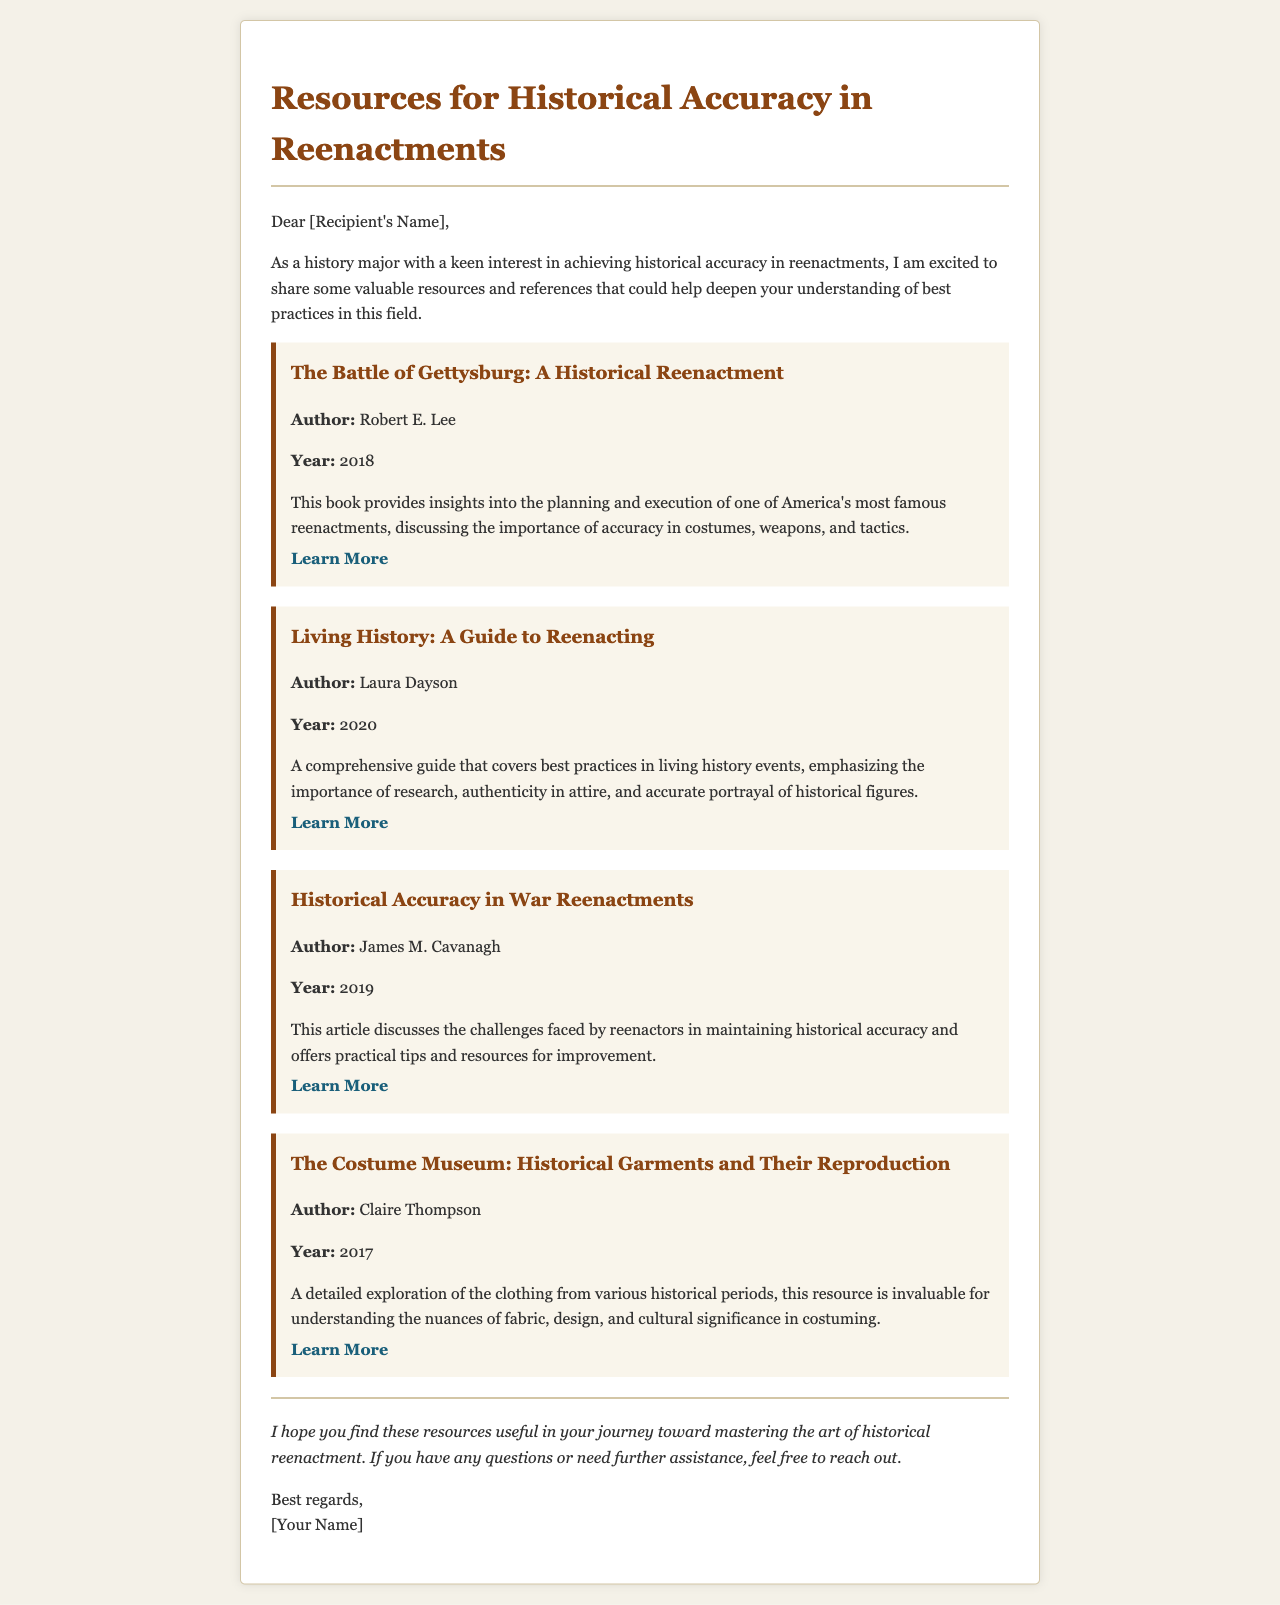what is the title of the document? The title of the document is prominently displayed at the top in the header section.
Answer: Resources for Historical Accuracy in Reenactments who is the author of "Living History: A Guide to Reenacting"? The document lists the authors of various resources, including this book.
Answer: Laura Dayson what year was "The Costume Museum: Historical Garments and Their Reproduction" published? The document specifies the publication year for each resource included.
Answer: 2017 which resource discusses the challenges faced by reenactors? The document outlines the focus of each listed resource, highlighting their main themes.
Answer: Historical Accuracy in War Reenactments what is the overall purpose of the email? The main intent of the email is articulated in the introductory paragraph, outlining what the recipient can expect.
Answer: To share valuable resources and references for historical accuracy in reenactments what type of resource is "The Battle of Gettysburg: A Historical Reenactment"? The document categorizes resources by their content and focus, providing context for each one.
Answer: Book which author's work emphasizes the importance of authenticity in attire? Each resource is attributed to its respective author, with specific themes highlighted in their descriptions.
Answer: Laura Dayson 